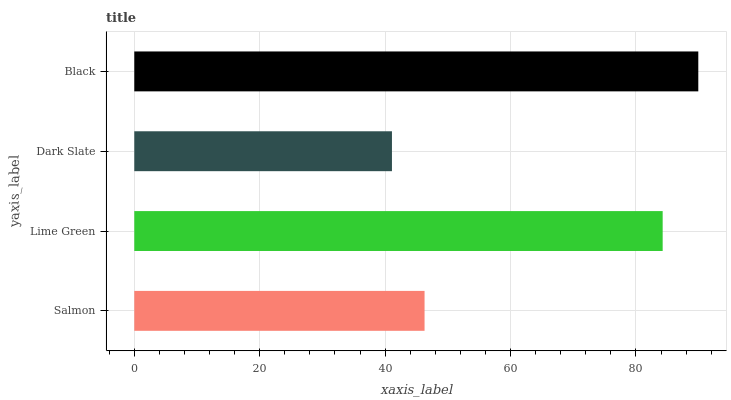Is Dark Slate the minimum?
Answer yes or no. Yes. Is Black the maximum?
Answer yes or no. Yes. Is Lime Green the minimum?
Answer yes or no. No. Is Lime Green the maximum?
Answer yes or no. No. Is Lime Green greater than Salmon?
Answer yes or no. Yes. Is Salmon less than Lime Green?
Answer yes or no. Yes. Is Salmon greater than Lime Green?
Answer yes or no. No. Is Lime Green less than Salmon?
Answer yes or no. No. Is Lime Green the high median?
Answer yes or no. Yes. Is Salmon the low median?
Answer yes or no. Yes. Is Black the high median?
Answer yes or no. No. Is Lime Green the low median?
Answer yes or no. No. 